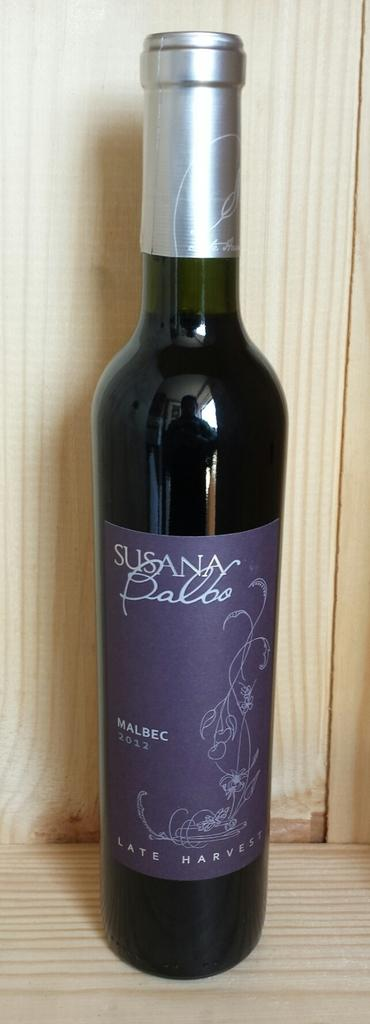<image>
Describe the image concisely. A bottle of 2012 Malbec sits on a wood shelf. 